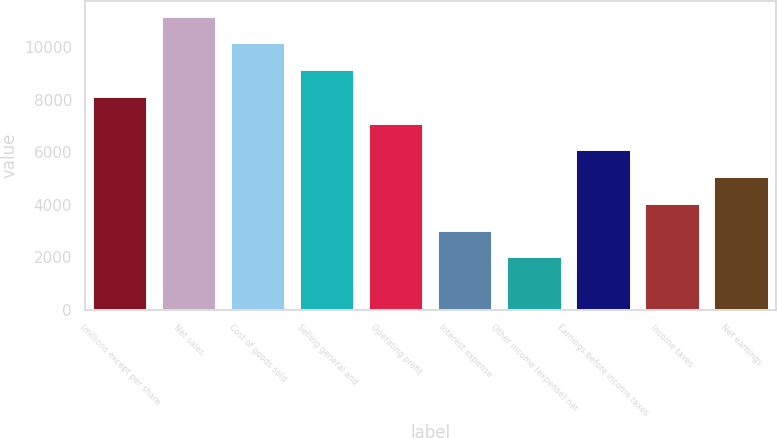<chart> <loc_0><loc_0><loc_500><loc_500><bar_chart><fcel>(millions except per share<fcel>Net sales<fcel>Cost of goods sold<fcel>Selling general and<fcel>Operating profit<fcel>Interest expense<fcel>Other income (expense) net<fcel>Earnings before income taxes<fcel>Income taxes<fcel>Net earnings<nl><fcel>8142.2<fcel>11194.6<fcel>10177.2<fcel>9159.68<fcel>7124.72<fcel>3054.8<fcel>2037.32<fcel>6107.24<fcel>4072.28<fcel>5089.76<nl></chart> 